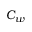<formula> <loc_0><loc_0><loc_500><loc_500>C _ { w }</formula> 